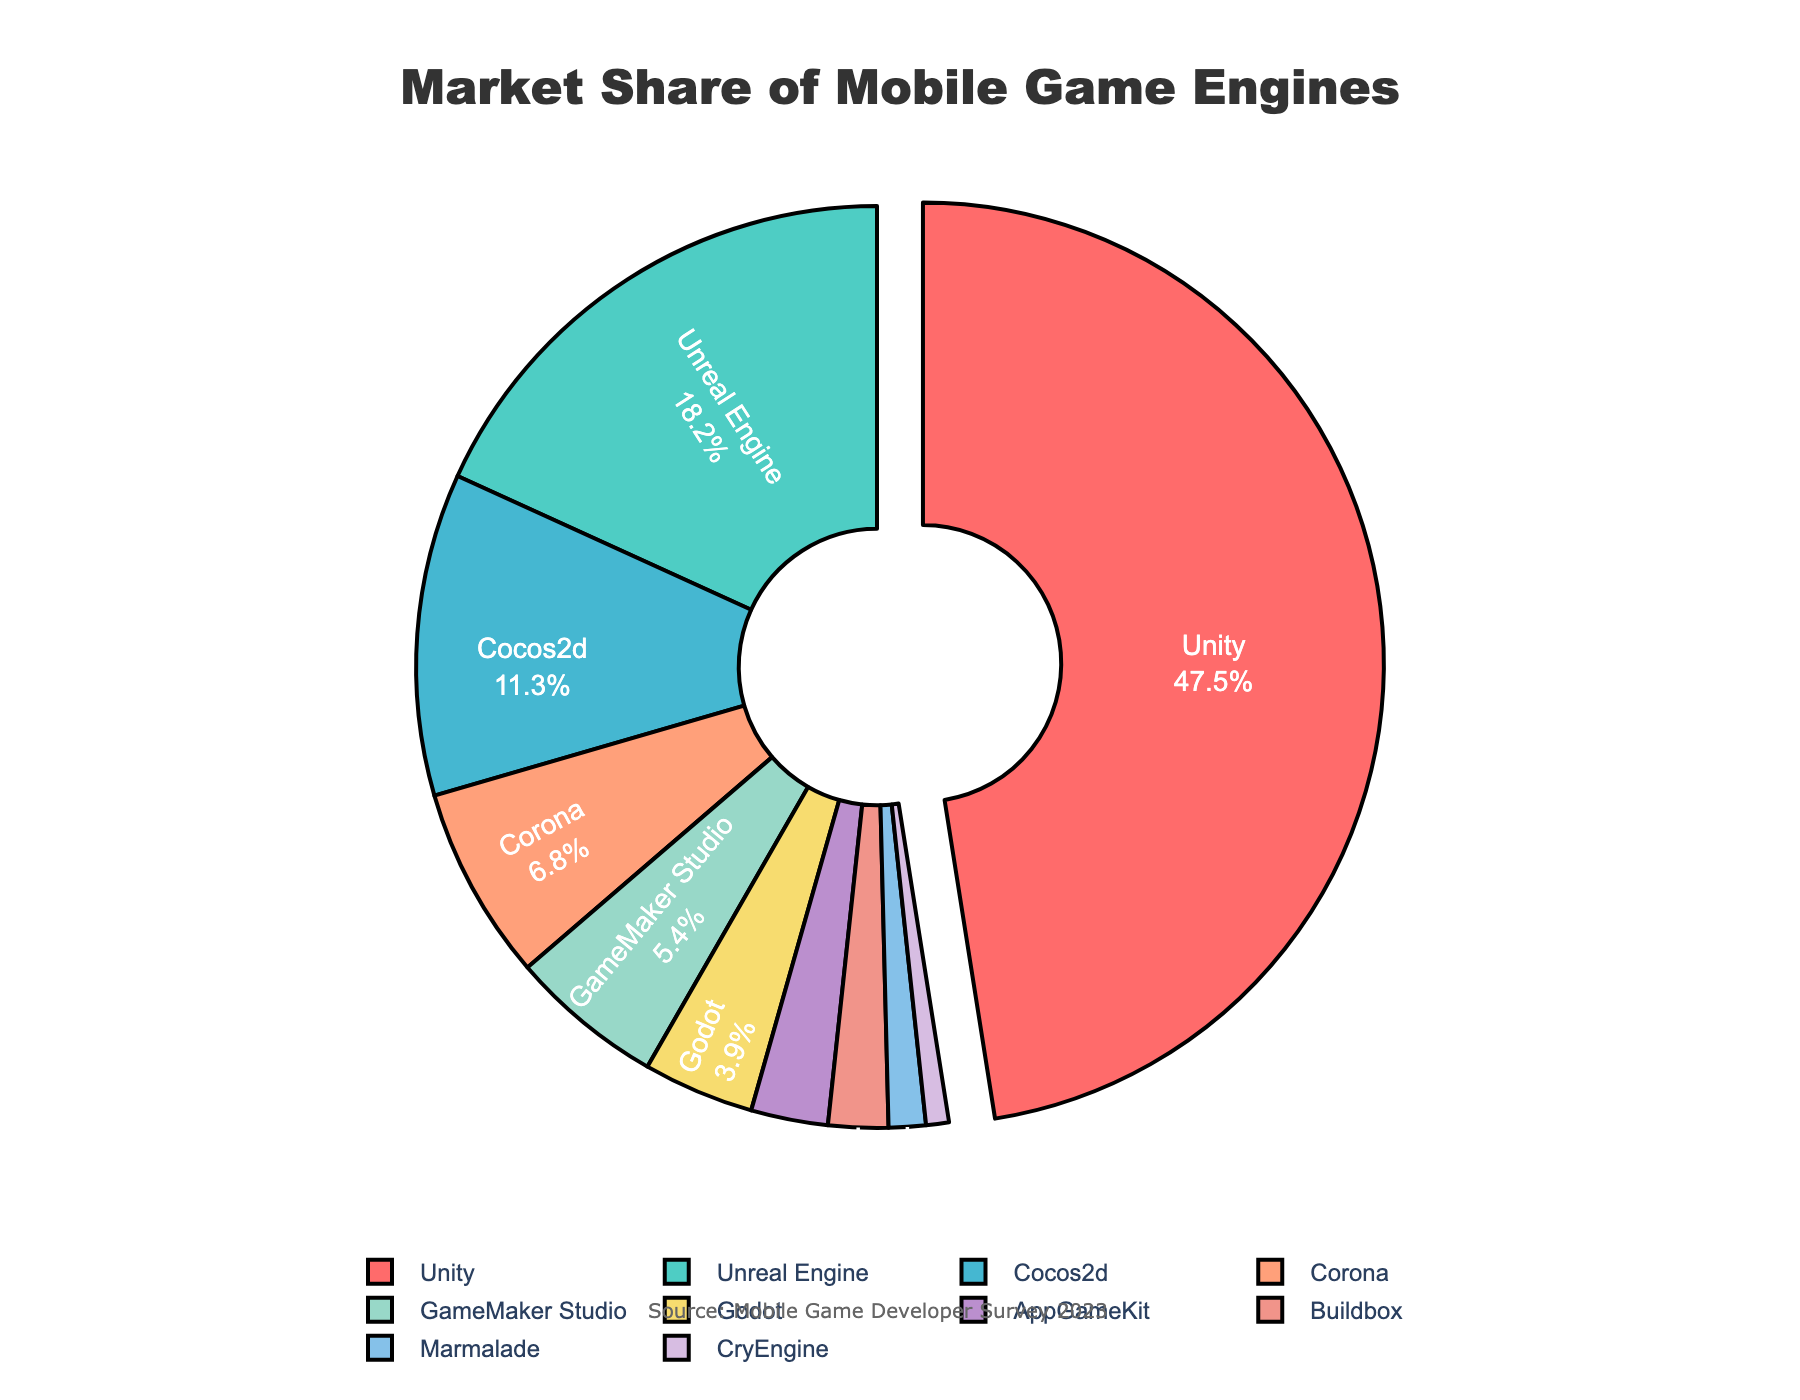What's the engine with the highest market share? By looking at the pie chart, we can see that the largest segment is marked and that belongs to Unity with a market share of 47.5%.
Answer: Unity How much larger is Unity's market share compared to Unreal Engine's? Unity has 47.5% market share while Unreal Engine has 18.2%. To find how much larger Unity's share is, we subtract Unreal Engine's share from Unity's: 47.5% - 18.2% = 29.3%.
Answer: 29.3% What is the combined market share of the three least used engines? The three engines with the smallest market shares are CryEngine (0.8%), Marmalade (1.3%), and Buildbox (2.1%). The combined share is calculated by adding their market shares: 0.8% + 1.3% + 2.1% = 4.2%.
Answer: 4.2% Which game engine appears with a slightly different visual attribute to emphasize its portion? The pie chart visually emphasizes one engine by pulling its segment outward; in this case, it is Unity.
Answer: Unity What's the difference in market share between Cocos2d and GameMaker Studio? Cocos2d has a market share of 11.3%, and GameMaker Studio has 5.4%. Subtracting the two gives us the difference: 11.3% - 5.4% = 5.9%.
Answer: 5.9% Between Corona and Cocos2d, which engine has more market share, and by how much? Corona has a market share of 6.8% and Cocos2d has 11.3%. Cocos2d has the larger market share. The difference is 11.3% - 6.8% = 4.5%.
Answer: Cocos2d by 4.5% What percentage of the market is held by engines other than Unity and Unreal Engine? Unity and Unreal Engine together hold 47.5% + 18.2% = 65.7% of the market. Therefore, the remaining market share held by other engines is 100% - 65.7% = 34.3%.
Answer: 34.3% Which color represents GameMaker Studio in the pie chart? By referring to the color palette used, GameMaker Studio is represented by the fifth color, which is light green.
Answer: light green 